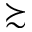<formula> <loc_0><loc_0><loc_500><loc_500>\succ s i m</formula> 